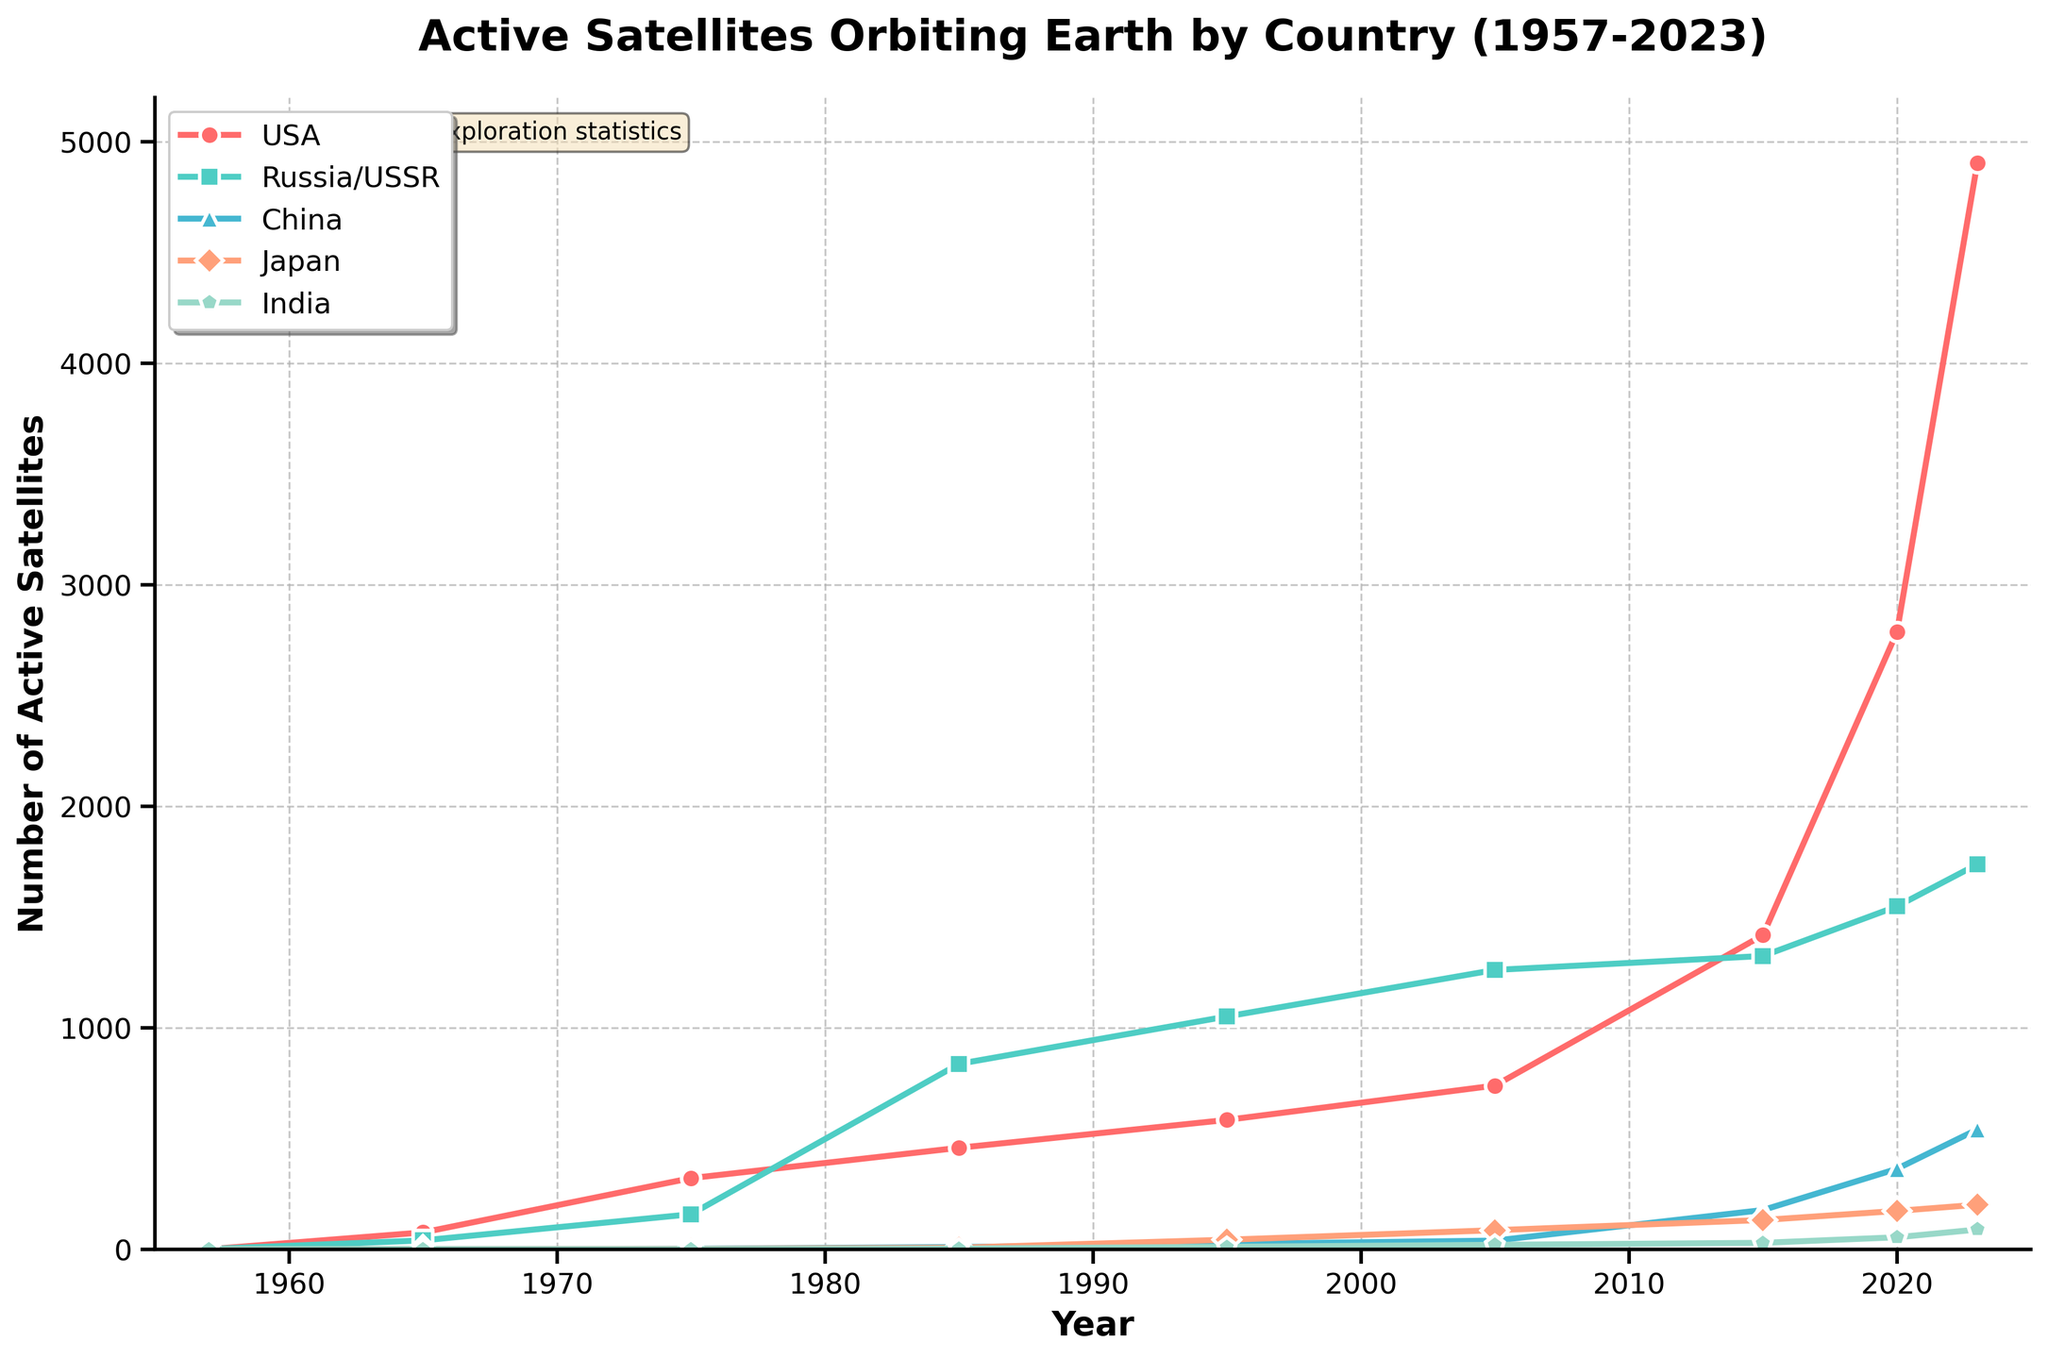Which country had the greatest number of active satellites in 2023? Looking at the year 2023 on the x-axis and comparing the y-values (number of active satellites) for each country, the USA has the highest value.
Answer: USA How did the number of active satellites for China change from 2015 to 2020? Refer to the y-values for China at the years 2015 and 2020. In 2015, China had 177 satellites, and in 2020, it had 363 satellites. The change is 363 - 177 = 186.
Answer: Increased by 186 Which country had the smallest number of active satellites in 1985? Look at the y-values for each country in 1985. India has the smallest value with only 3 satellites.
Answer: India Compare the number of active satellites between the USA and Russia/USSR in 1975. Which one had more, and by how much? Look at the y-values for the USA and Russia/USSR in 1975. The USA had 321 satellites, and Russia/USSR had 158. The difference is 321 - 158 = 163.
Answer: USA by 163 By how many satellites did Japan's count increase from 2005 to 2023? Refer to the y-values for Japan in 2005 and 2023. In 2005, Japan had 86 satellites, and in 2023, it had 201. The increase is 201 - 86 = 115.
Answer: Increased by 115 What is the average number of active satellites for India between 1995 and 2023? Find the y-values for India in each of the years 1995, 2005, 2015, 2020, and 2023, which are 11, 20, 29, 54, and 89 respectively. Sum these values (11 + 20 + 29 + 54 + 89 = 203) and divide by the number of years (203 / 5).
Answer: 40.6 Which two countries had the closest number of active satellites in 2020? Compare the y-values for each country in 2020. The USA had 2787, Russia/USSR 1548, China 363, Japan 173, and India 54. The closest numbers are Japan and China with a difference of 363 - 173 = 190.
Answer: China and Japan What visual difference can you observe between the trends for the USA and Russia/USSR from 1957 to 2023? The USA shows a steady increase in the number of active satellites, especially significant after 2005. Russia/USSR has higher initial growth but stabilizes and shows lesser growth after 2005 compared to the USA.
Answer: The USA has a steeper increase after 2005, while Russia/USSR stabilizes Which country showed the largest increase in satellite numbers from 1957 to 1985? Compare the increase in y-values for each country from 1957 to 1985. The USSR/Russia increased from 1 to 837, which is the largest jump.
Answer: Russia/USSR 